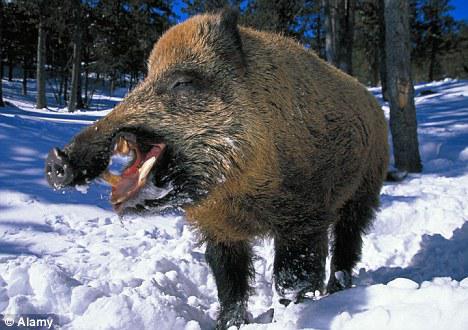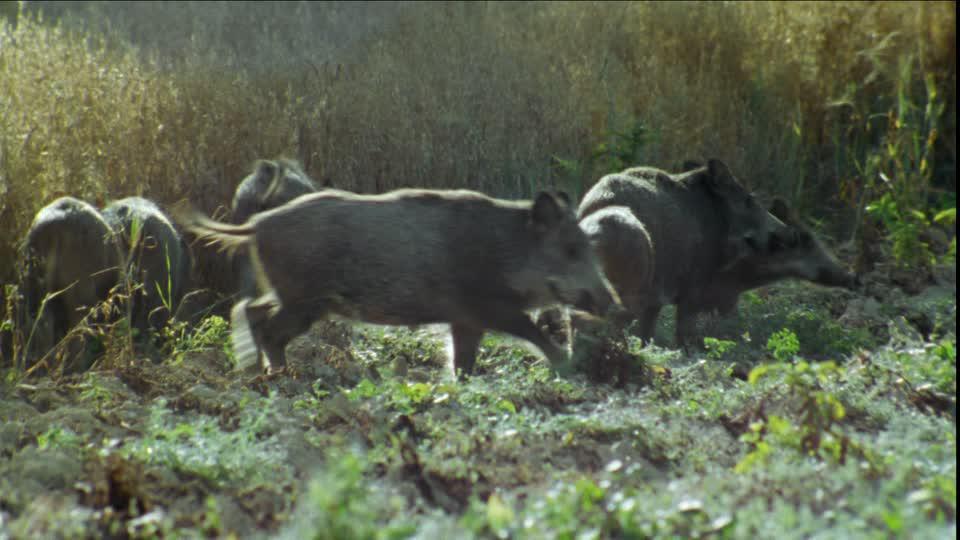The first image is the image on the left, the second image is the image on the right. Evaluate the accuracy of this statement regarding the images: "Only one image has animals in the snow.". Is it true? Answer yes or no. Yes. 